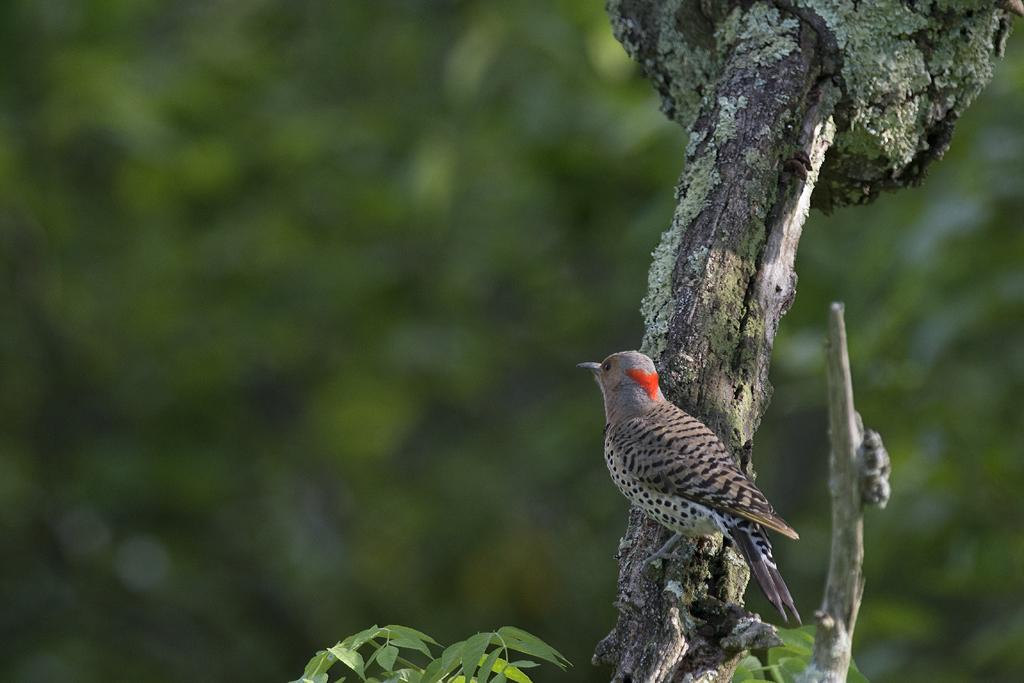What type of animal is in the image? There is a bird in the image. What color is the bird? The bird is grey in color. Where is the bird located in the image? The bird is on the branch of a tree. What can be seen in the background of the image? There are trees in the background of the image. Are there any icicles hanging from the bird's beak in the image? There are no icicles present in the image, and the bird's beak is not visible. 